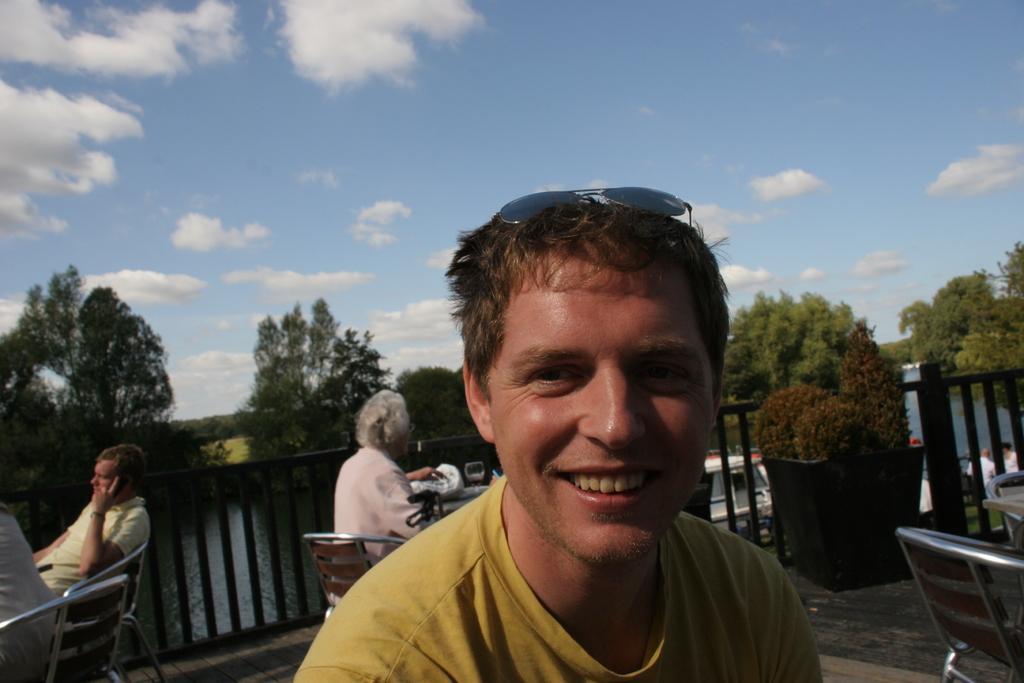How would you summarize this image in a sentence or two? On this photo there are many chairs and tables. In the middle one person wearing a yellow t shirt is smiling,Sunglasses is on his head. Behind him many people are sitting on chair. There is a fence around the roof. In the right there is a plant pot. In the background there are many trees. There is a pool in the background. The sky is cloudy. 